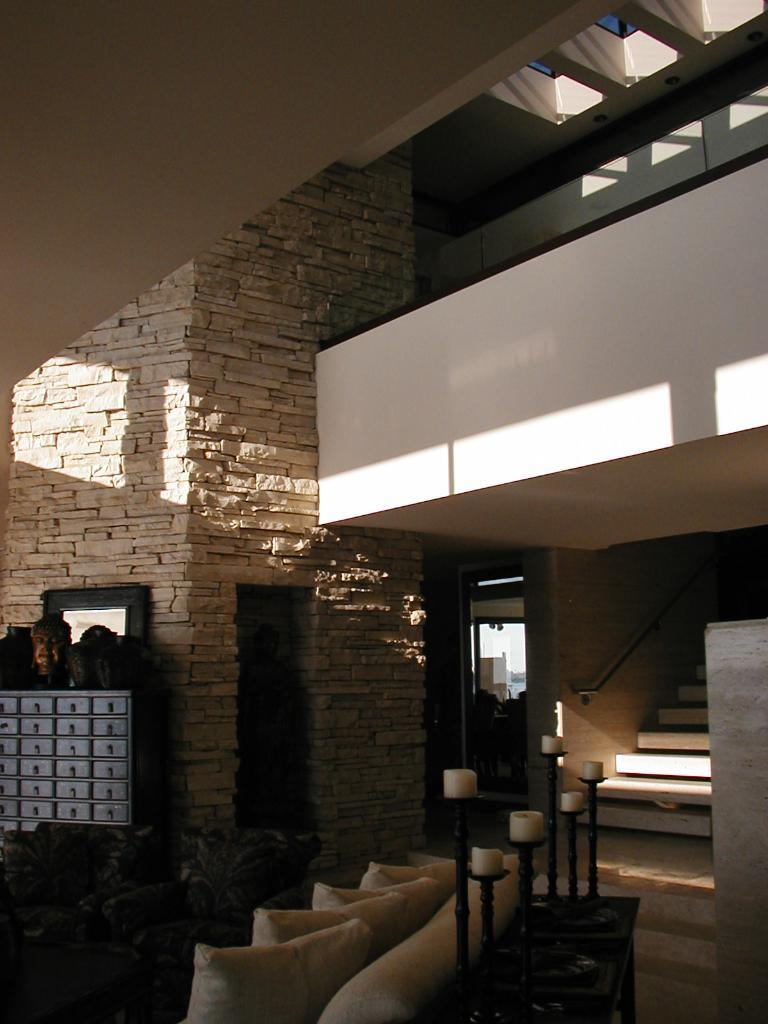What type of room is shown in the image? The image depicts an inner view of a living room. What furniture is present in the living room? There is a sofa with pillows in the living room. What decorative items can be seen on a table in the living room? There are candles placed on a table in the living room. Are there any architectural features in the living room? Yes, there are stairs in the living room. What other elements can be found in the living room? There are plants, a door, and a cupboard in the living room. Where is the pail located in the living room? There is no pail present in the living room; it is not mentioned in the provided facts. What type of writing instrument is used in the living room? The image does not show any writing instruments, such as a quill, being used in the living room. 